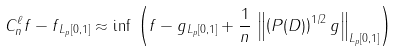Convert formula to latex. <formula><loc_0><loc_0><loc_500><loc_500>\| C ^ { \ell } _ { n } f - f \| _ { L _ { p } [ 0 , 1 ] } \approx \inf \, \left ( \| f - g \| _ { L _ { p } [ 0 , 1 ] } + \frac { 1 } { n } \, \left \| \left ( P ( D ) \right ) ^ { 1 / 2 } g \right \| _ { L _ { p } [ 0 , 1 ] } \right )</formula> 